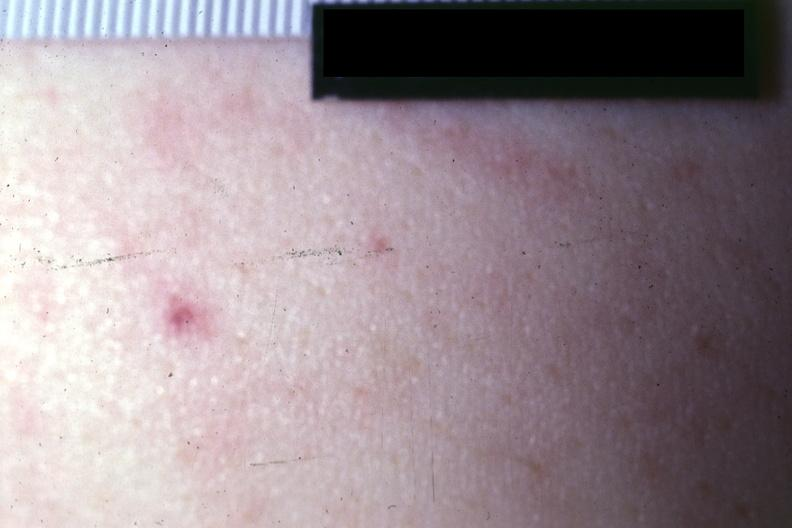what does this image show?
Answer the question using a single word or phrase. Close-up photo quite good 